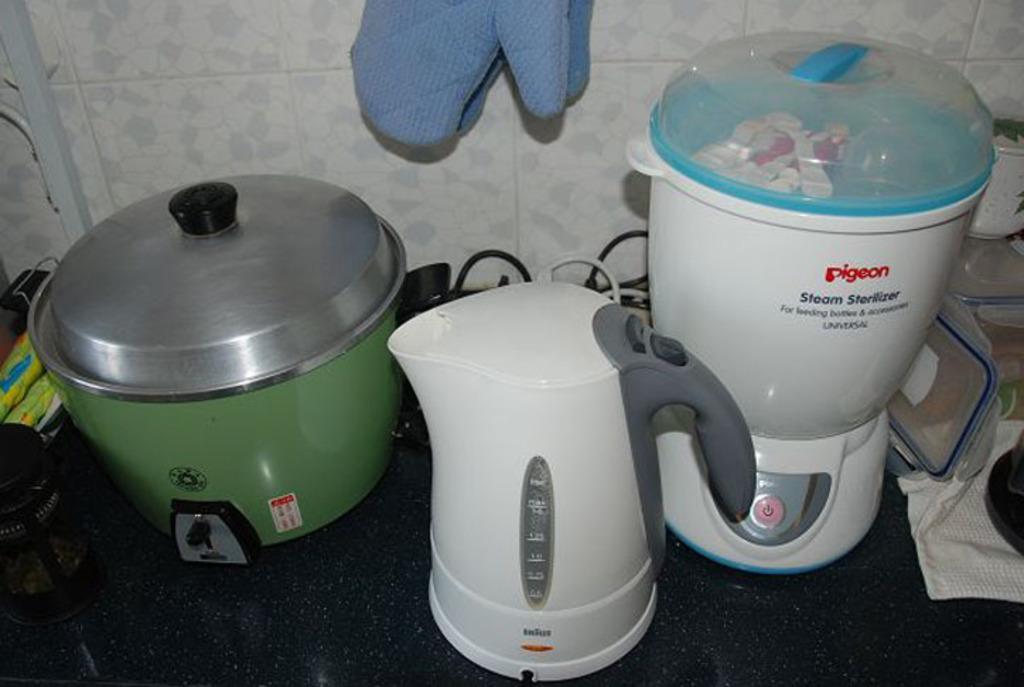Describe this image in one or two sentences. This image consists of rice cooker along with mixer grinders kept on the floor. It looks like a kitchen. In the background, there is a wall covered with white color tiles. To the top, there are gloves. To the right, there are boxes. 